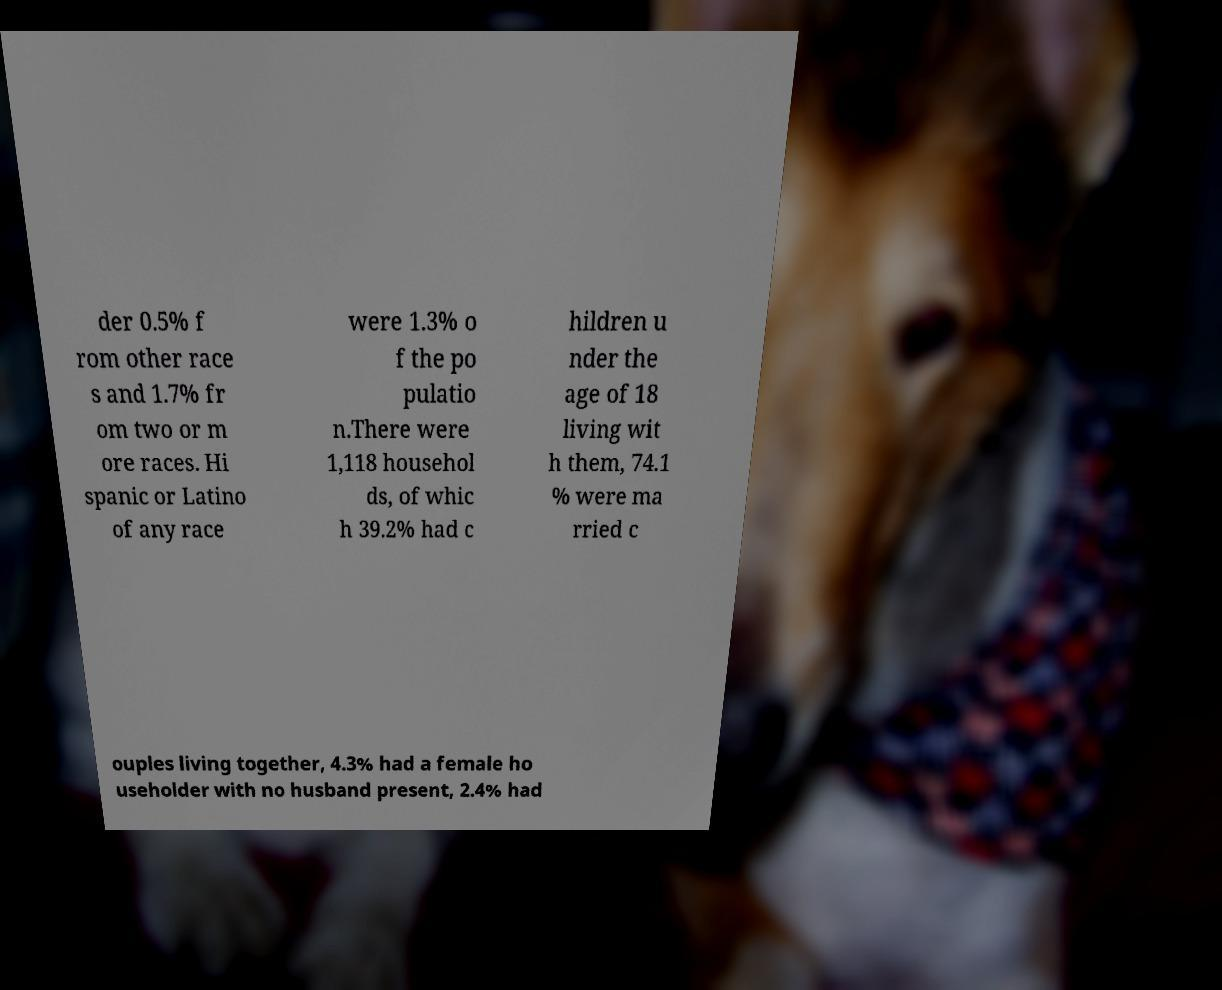Could you assist in decoding the text presented in this image and type it out clearly? der 0.5% f rom other race s and 1.7% fr om two or m ore races. Hi spanic or Latino of any race were 1.3% o f the po pulatio n.There were 1,118 househol ds, of whic h 39.2% had c hildren u nder the age of 18 living wit h them, 74.1 % were ma rried c ouples living together, 4.3% had a female ho useholder with no husband present, 2.4% had 